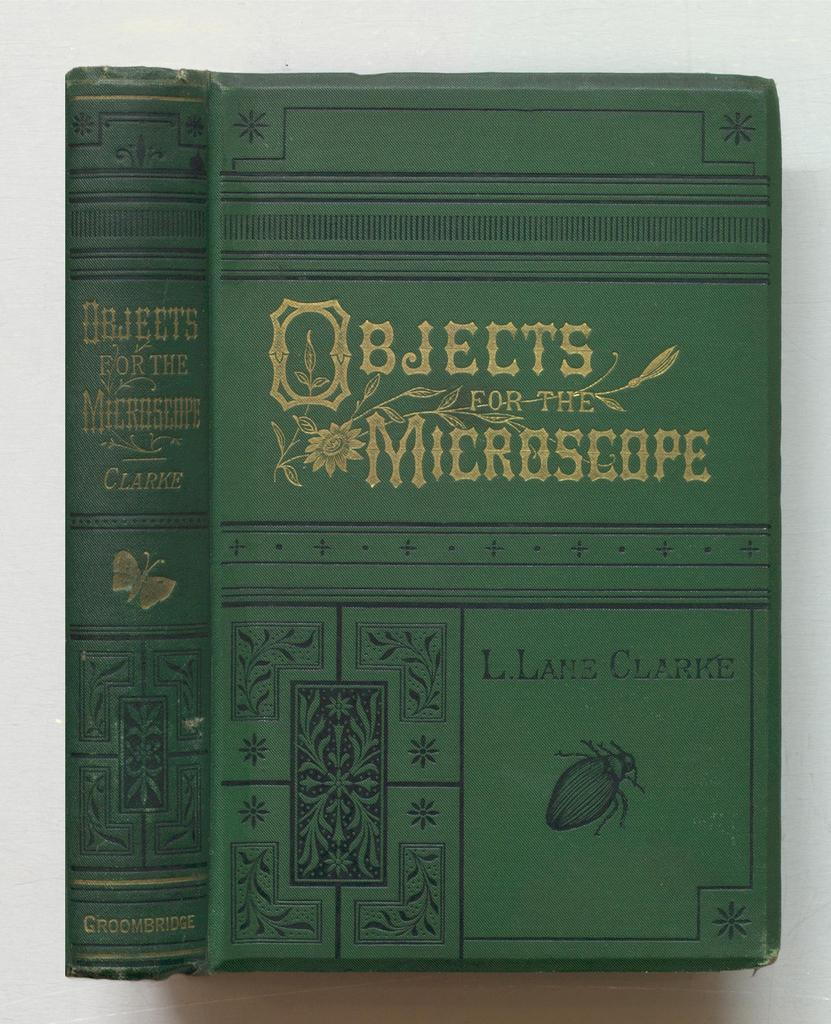<image>
Provide a brief description of the given image. An old looking book which has the words Objects for the Microscope in fancy gold lettering. 